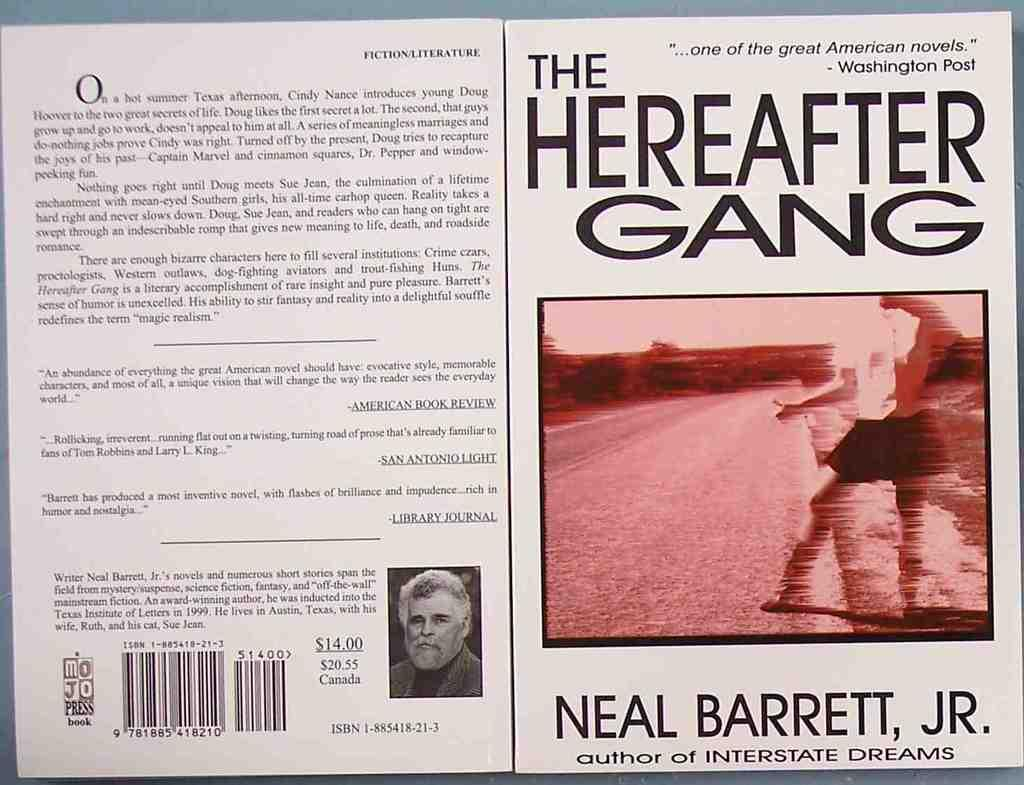<image>
Write a terse but informative summary of the picture. The front and back cover of a book written by Neal Barrett, Jr. 